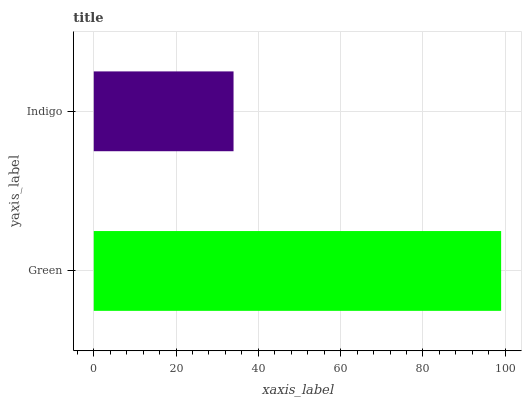Is Indigo the minimum?
Answer yes or no. Yes. Is Green the maximum?
Answer yes or no. Yes. Is Indigo the maximum?
Answer yes or no. No. Is Green greater than Indigo?
Answer yes or no. Yes. Is Indigo less than Green?
Answer yes or no. Yes. Is Indigo greater than Green?
Answer yes or no. No. Is Green less than Indigo?
Answer yes or no. No. Is Green the high median?
Answer yes or no. Yes. Is Indigo the low median?
Answer yes or no. Yes. Is Indigo the high median?
Answer yes or no. No. Is Green the low median?
Answer yes or no. No. 